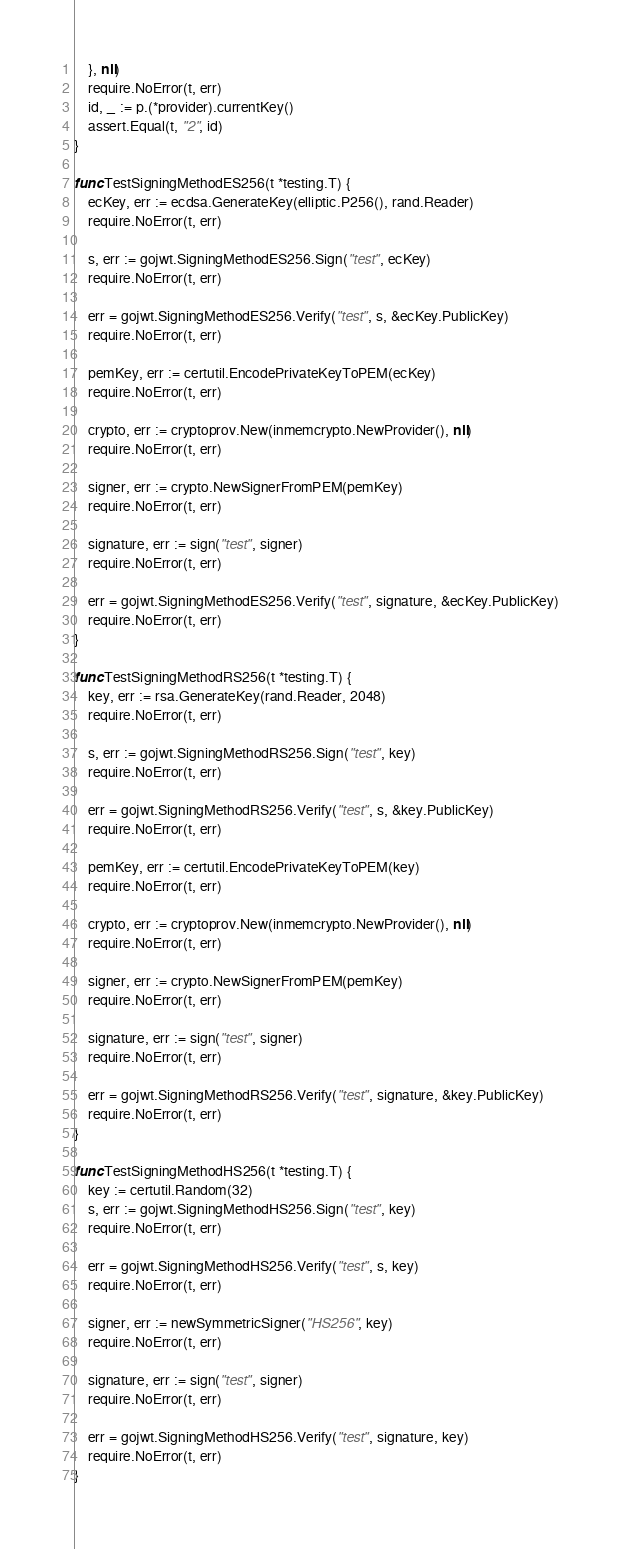Convert code to text. <code><loc_0><loc_0><loc_500><loc_500><_Go_>	}, nil)
	require.NoError(t, err)
	id, _ := p.(*provider).currentKey()
	assert.Equal(t, "2", id)
}

func TestSigningMethodES256(t *testing.T) {
	ecKey, err := ecdsa.GenerateKey(elliptic.P256(), rand.Reader)
	require.NoError(t, err)

	s, err := gojwt.SigningMethodES256.Sign("test", ecKey)
	require.NoError(t, err)

	err = gojwt.SigningMethodES256.Verify("test", s, &ecKey.PublicKey)
	require.NoError(t, err)

	pemKey, err := certutil.EncodePrivateKeyToPEM(ecKey)
	require.NoError(t, err)

	crypto, err := cryptoprov.New(inmemcrypto.NewProvider(), nil)
	require.NoError(t, err)

	signer, err := crypto.NewSignerFromPEM(pemKey)
	require.NoError(t, err)

	signature, err := sign("test", signer)
	require.NoError(t, err)

	err = gojwt.SigningMethodES256.Verify("test", signature, &ecKey.PublicKey)
	require.NoError(t, err)
}

func TestSigningMethodRS256(t *testing.T) {
	key, err := rsa.GenerateKey(rand.Reader, 2048)
	require.NoError(t, err)

	s, err := gojwt.SigningMethodRS256.Sign("test", key)
	require.NoError(t, err)

	err = gojwt.SigningMethodRS256.Verify("test", s, &key.PublicKey)
	require.NoError(t, err)

	pemKey, err := certutil.EncodePrivateKeyToPEM(key)
	require.NoError(t, err)

	crypto, err := cryptoprov.New(inmemcrypto.NewProvider(), nil)
	require.NoError(t, err)

	signer, err := crypto.NewSignerFromPEM(pemKey)
	require.NoError(t, err)

	signature, err := sign("test", signer)
	require.NoError(t, err)

	err = gojwt.SigningMethodRS256.Verify("test", signature, &key.PublicKey)
	require.NoError(t, err)
}

func TestSigningMethodHS256(t *testing.T) {
	key := certutil.Random(32)
	s, err := gojwt.SigningMethodHS256.Sign("test", key)
	require.NoError(t, err)

	err = gojwt.SigningMethodHS256.Verify("test", s, key)
	require.NoError(t, err)

	signer, err := newSymmetricSigner("HS256", key)
	require.NoError(t, err)

	signature, err := sign("test", signer)
	require.NoError(t, err)

	err = gojwt.SigningMethodHS256.Verify("test", signature, key)
	require.NoError(t, err)
}
</code> 